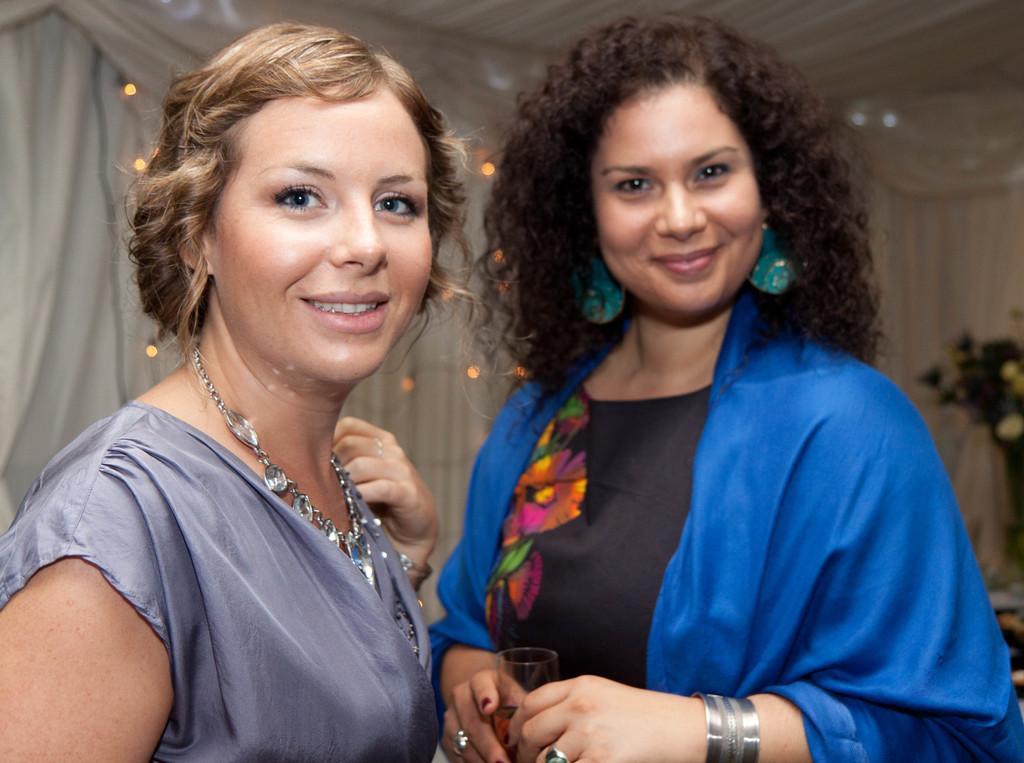In one or two sentences, can you explain what this image depicts? In this image we can see this woman wearing dress and necklace is smiling and this woman wearing blue and black dress, earring, bangles is holding a glass with drink and smiling. The background of the image is slightly blurred, where we can see the curtains, lights and the flower vase here. 